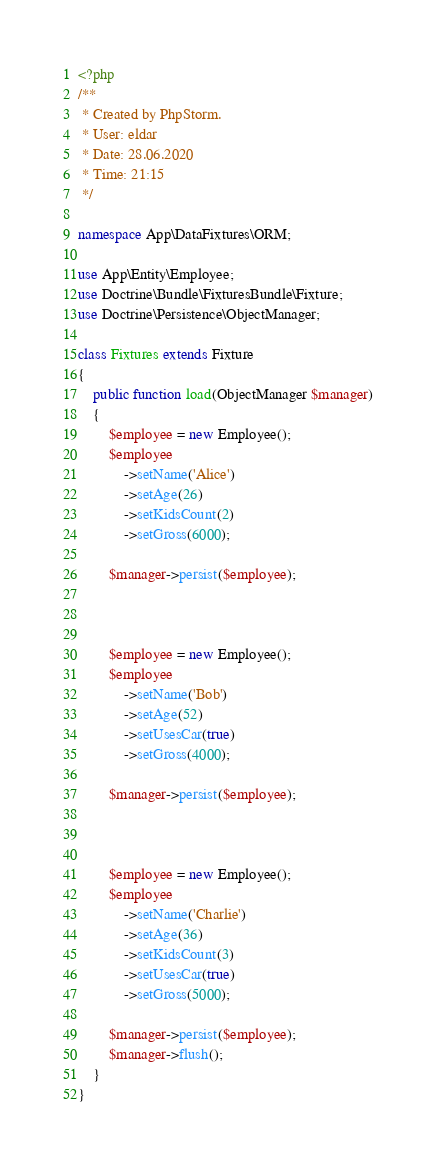Convert code to text. <code><loc_0><loc_0><loc_500><loc_500><_PHP_><?php
/**
 * Created by PhpStorm.
 * User: eldar
 * Date: 28.06.2020
 * Time: 21:15
 */

namespace App\DataFixtures\ORM;

use App\Entity\Employee;
use Doctrine\Bundle\FixturesBundle\Fixture;
use Doctrine\Persistence\ObjectManager;

class Fixtures extends Fixture
{
    public function load(ObjectManager $manager)
    {
        $employee = new Employee();
        $employee
            ->setName('Alice')
            ->setAge(26)
            ->setKidsCount(2)
            ->setGross(6000);

        $manager->persist($employee);



        $employee = new Employee();
        $employee
            ->setName('Bob')
            ->setAge(52)
            ->setUsesCar(true)
            ->setGross(4000);

        $manager->persist($employee);



        $employee = new Employee();
        $employee
            ->setName('Charlie')
            ->setAge(36)
            ->setKidsCount(3)
            ->setUsesCar(true)
            ->setGross(5000);

        $manager->persist($employee);
        $manager->flush();
    }
}</code> 